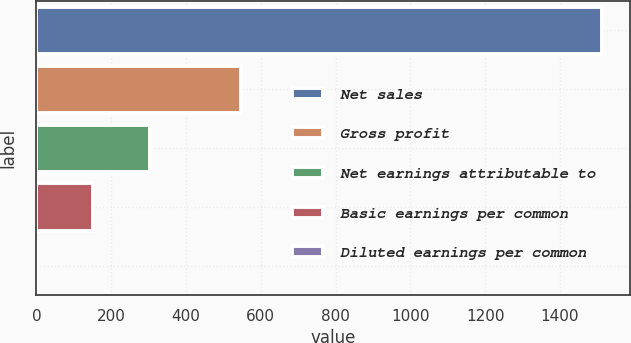Convert chart to OTSL. <chart><loc_0><loc_0><loc_500><loc_500><bar_chart><fcel>Net sales<fcel>Gross profit<fcel>Net earnings attributable to<fcel>Basic earnings per common<fcel>Diluted earnings per common<nl><fcel>1512.7<fcel>546.5<fcel>303.63<fcel>152.5<fcel>1.37<nl></chart> 